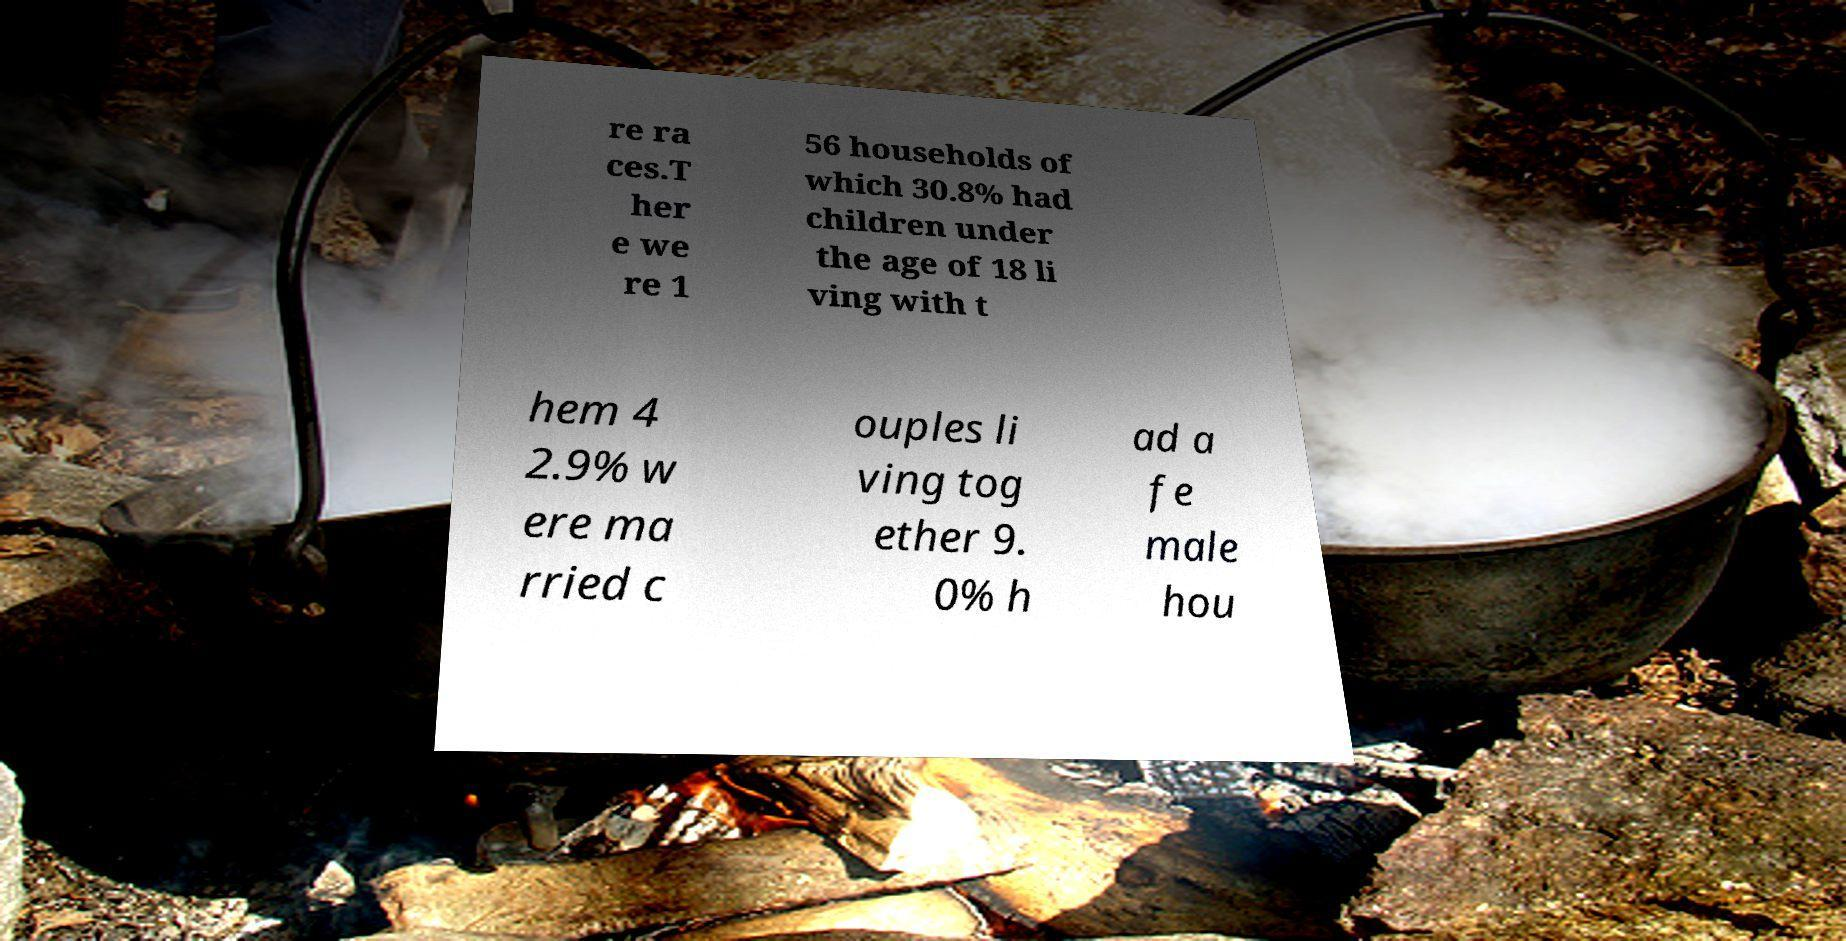For documentation purposes, I need the text within this image transcribed. Could you provide that? re ra ces.T her e we re 1 56 households of which 30.8% had children under the age of 18 li ving with t hem 4 2.9% w ere ma rried c ouples li ving tog ether 9. 0% h ad a fe male hou 